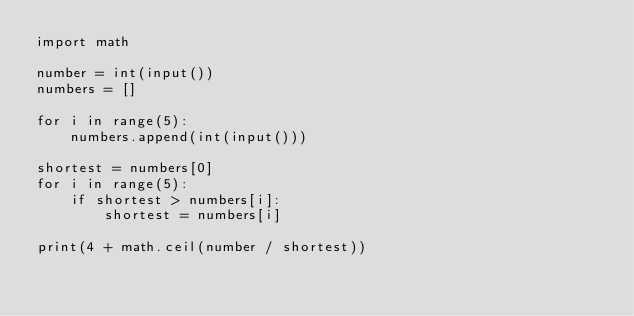<code> <loc_0><loc_0><loc_500><loc_500><_Python_>import math

number = int(input())
numbers = []

for i in range(5):
    numbers.append(int(input()))

shortest = numbers[0]
for i in range(5):
    if shortest > numbers[i]:
        shortest = numbers[i]

print(4 + math.ceil(number / shortest))</code> 